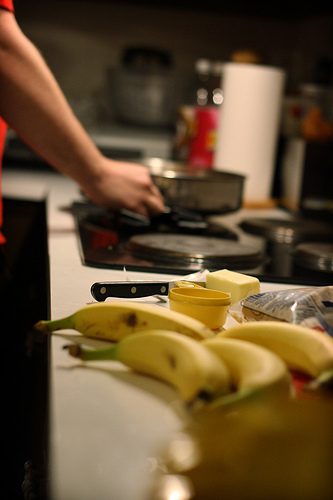Is the person to the right or to the left of the pot? The person is to the left of the pot, engaging possibly in preparing or cooking food. 